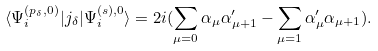Convert formula to latex. <formula><loc_0><loc_0><loc_500><loc_500>\langle \Psi ^ { ( p _ { \delta } , 0 ) } _ { i } | j _ { \delta } | \Psi ^ { ( s ) , 0 } _ { i } \rangle = 2 i ( \sum _ { \mu = 0 } \alpha _ { \mu } \alpha ^ { \prime } _ { \mu + 1 } - \sum _ { \mu = 1 } \alpha ^ { \prime } _ { \mu } \alpha _ { \mu + 1 } ) .</formula> 